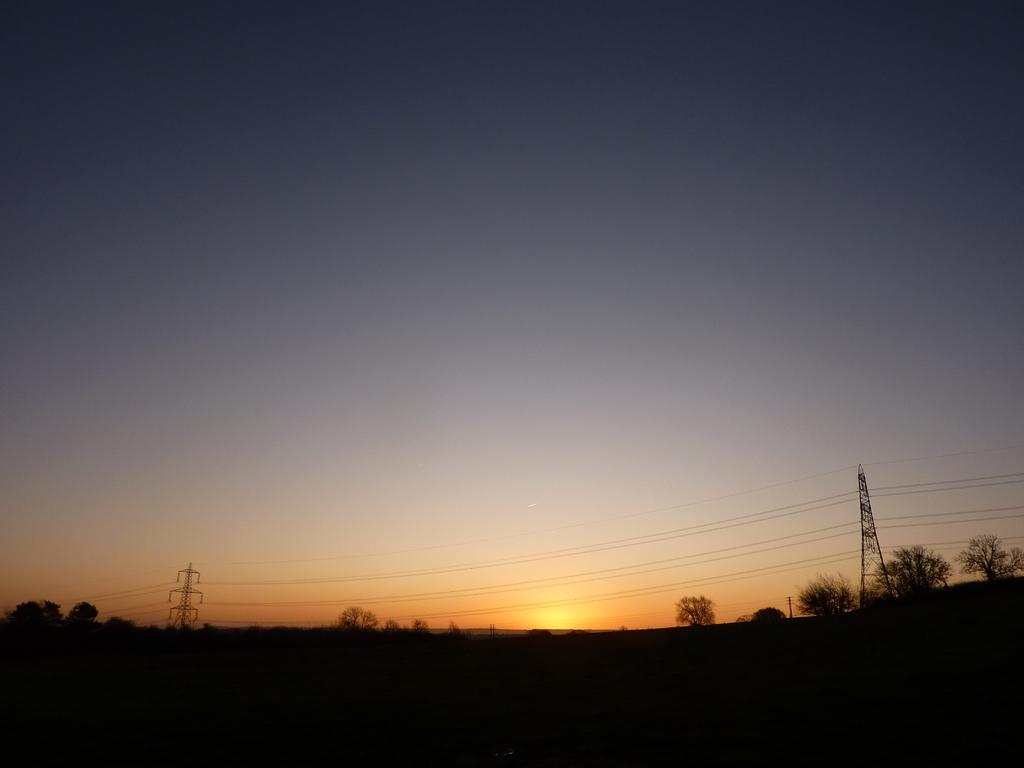What structures are present in the image? There are towers in the image. What else can be seen in the image besides the towers? There are wires and trees visible in the image. Where are the trees located in the image? The trees are on the bottom side of the image. What is visible in the background of the image? The sky and the sun are visible in the background of the image. What type of dinner is being served at the border in the image? There is no dinner or border present in the image; it features towers, wires, trees, and a sky with the sun visible. 